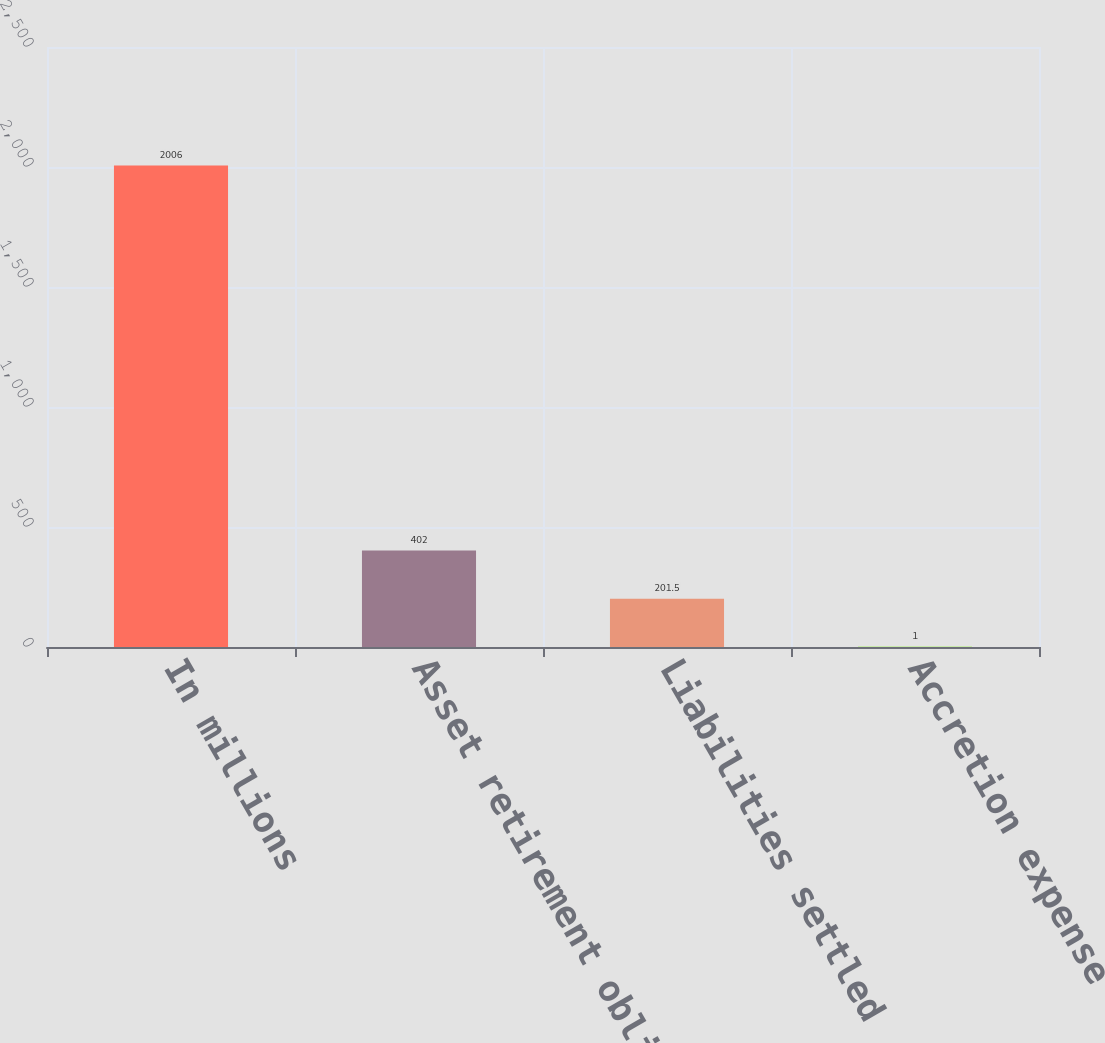Convert chart to OTSL. <chart><loc_0><loc_0><loc_500><loc_500><bar_chart><fcel>In millions<fcel>Asset retirement obligation at<fcel>Liabilities settled<fcel>Accretion expense<nl><fcel>2006<fcel>402<fcel>201.5<fcel>1<nl></chart> 